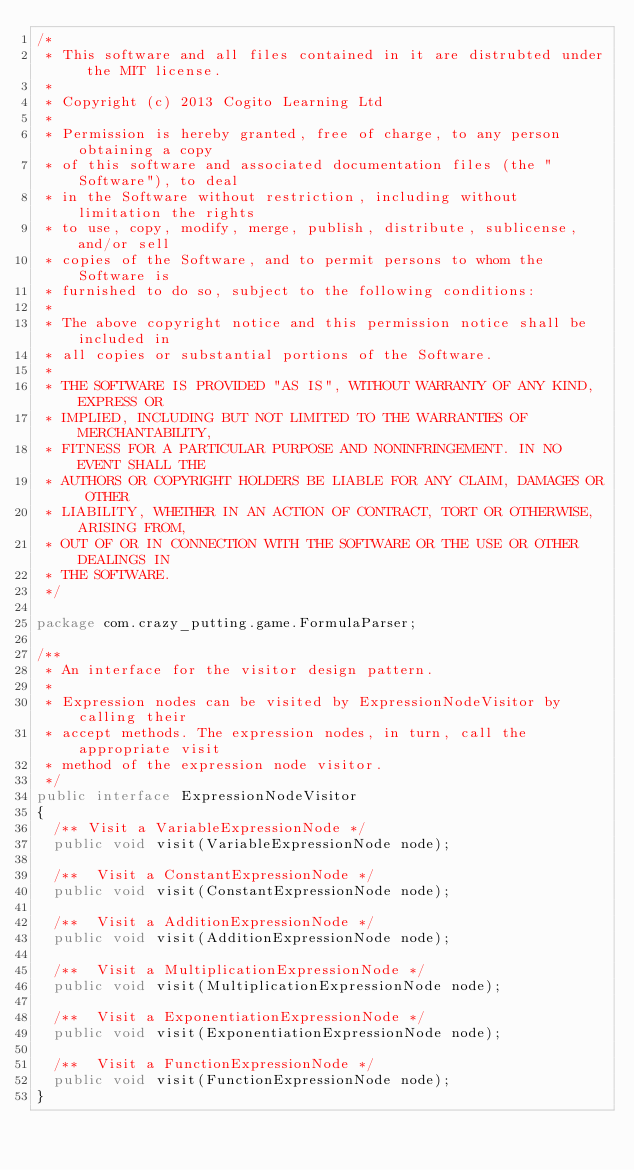<code> <loc_0><loc_0><loc_500><loc_500><_Java_>/*
 * This software and all files contained in it are distrubted under the MIT license.
 * 
 * Copyright (c) 2013 Cogito Learning Ltd
 * 
 * Permission is hereby granted, free of charge, to any person obtaining a copy
 * of this software and associated documentation files (the "Software"), to deal
 * in the Software without restriction, including without limitation the rights
 * to use, copy, modify, merge, publish, distribute, sublicense, and/or sell
 * copies of the Software, and to permit persons to whom the Software is
 * furnished to do so, subject to the following conditions:
 * 
 * The above copyright notice and this permission notice shall be included in
 * all copies or substantial portions of the Software.
 * 
 * THE SOFTWARE IS PROVIDED "AS IS", WITHOUT WARRANTY OF ANY KIND, EXPRESS OR
 * IMPLIED, INCLUDING BUT NOT LIMITED TO THE WARRANTIES OF MERCHANTABILITY,
 * FITNESS FOR A PARTICULAR PURPOSE AND NONINFRINGEMENT. IN NO EVENT SHALL THE
 * AUTHORS OR COPYRIGHT HOLDERS BE LIABLE FOR ANY CLAIM, DAMAGES OR OTHER
 * LIABILITY, WHETHER IN AN ACTION OF CONTRACT, TORT OR OTHERWISE, ARISING FROM,
 * OUT OF OR IN CONNECTION WITH THE SOFTWARE OR THE USE OR OTHER DEALINGS IN
 * THE SOFTWARE.
 */

package com.crazy_putting.game.FormulaParser;

/**
 * An interface for the visitor design pattern.
 * 
 * Expression nodes can be visited by ExpressionNodeVisitor by calling their
 * accept methods. The expression nodes, in turn, call the appropriate visit
 * method of the expression node visitor.
 */
public interface ExpressionNodeVisitor
{
  /** Visit a VariableExpressionNode */
  public void visit(VariableExpressionNode node);

  /**  Visit a ConstantExpressionNode */
  public void visit(ConstantExpressionNode node);

  /**  Visit a AdditionExpressionNode */
  public void visit(AdditionExpressionNode node);

  /**  Visit a MultiplicationExpressionNode */
  public void visit(MultiplicationExpressionNode node);

  /**  Visit a ExponentiationExpressionNode */
  public void visit(ExponentiationExpressionNode node);

  /**  Visit a FunctionExpressionNode */
  public void visit(FunctionExpressionNode node);
}
</code> 